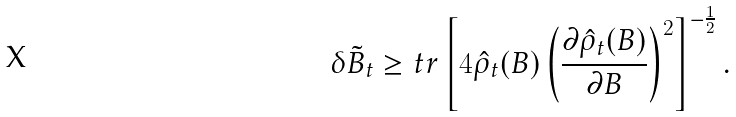Convert formula to latex. <formula><loc_0><loc_0><loc_500><loc_500>\delta \tilde { B } _ { t } \geq t r \left [ 4 \hat { \rho } _ { t } ( B ) \left ( \frac { \partial \hat { \rho } _ { t } ( B ) } { \partial B } \right ) ^ { 2 } \right ] ^ { - \frac { 1 } { 2 } } .</formula> 